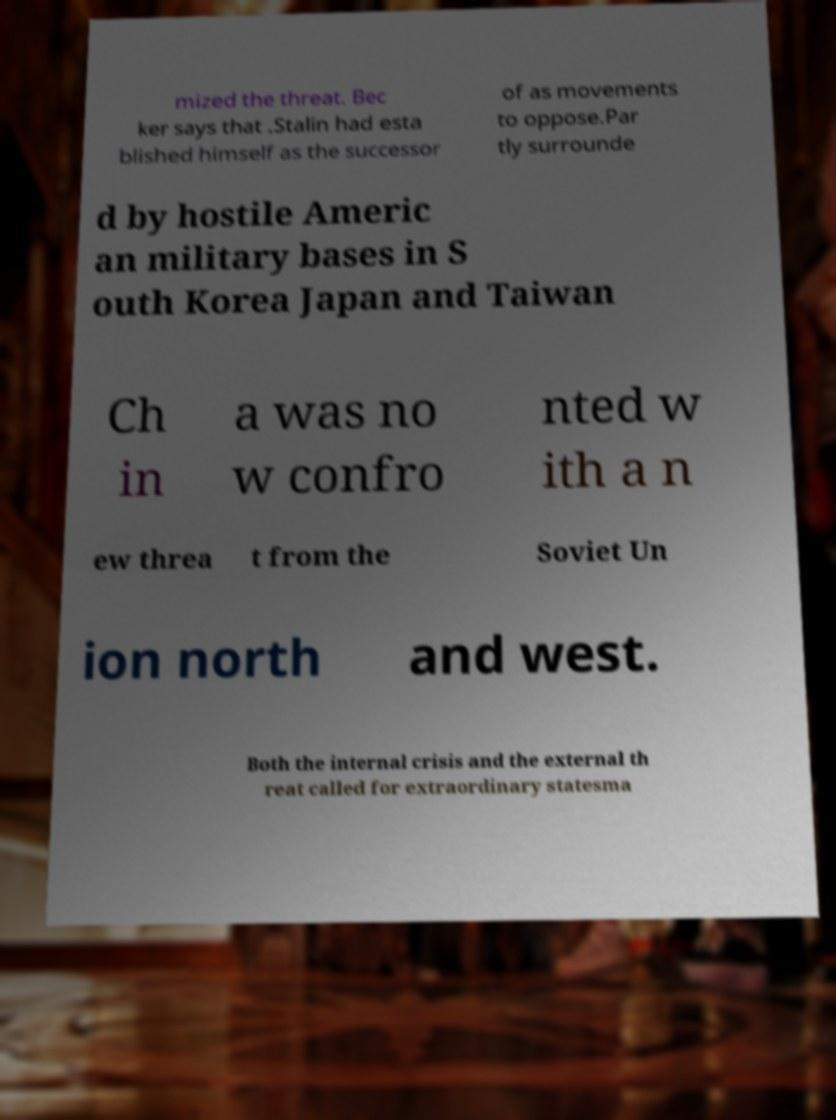What messages or text are displayed in this image? I need them in a readable, typed format. mized the threat. Bec ker says that .Stalin had esta blished himself as the successor of as movements to oppose.Par tly surrounde d by hostile Americ an military bases in S outh Korea Japan and Taiwan Ch in a was no w confro nted w ith a n ew threa t from the Soviet Un ion north and west. Both the internal crisis and the external th reat called for extraordinary statesma 